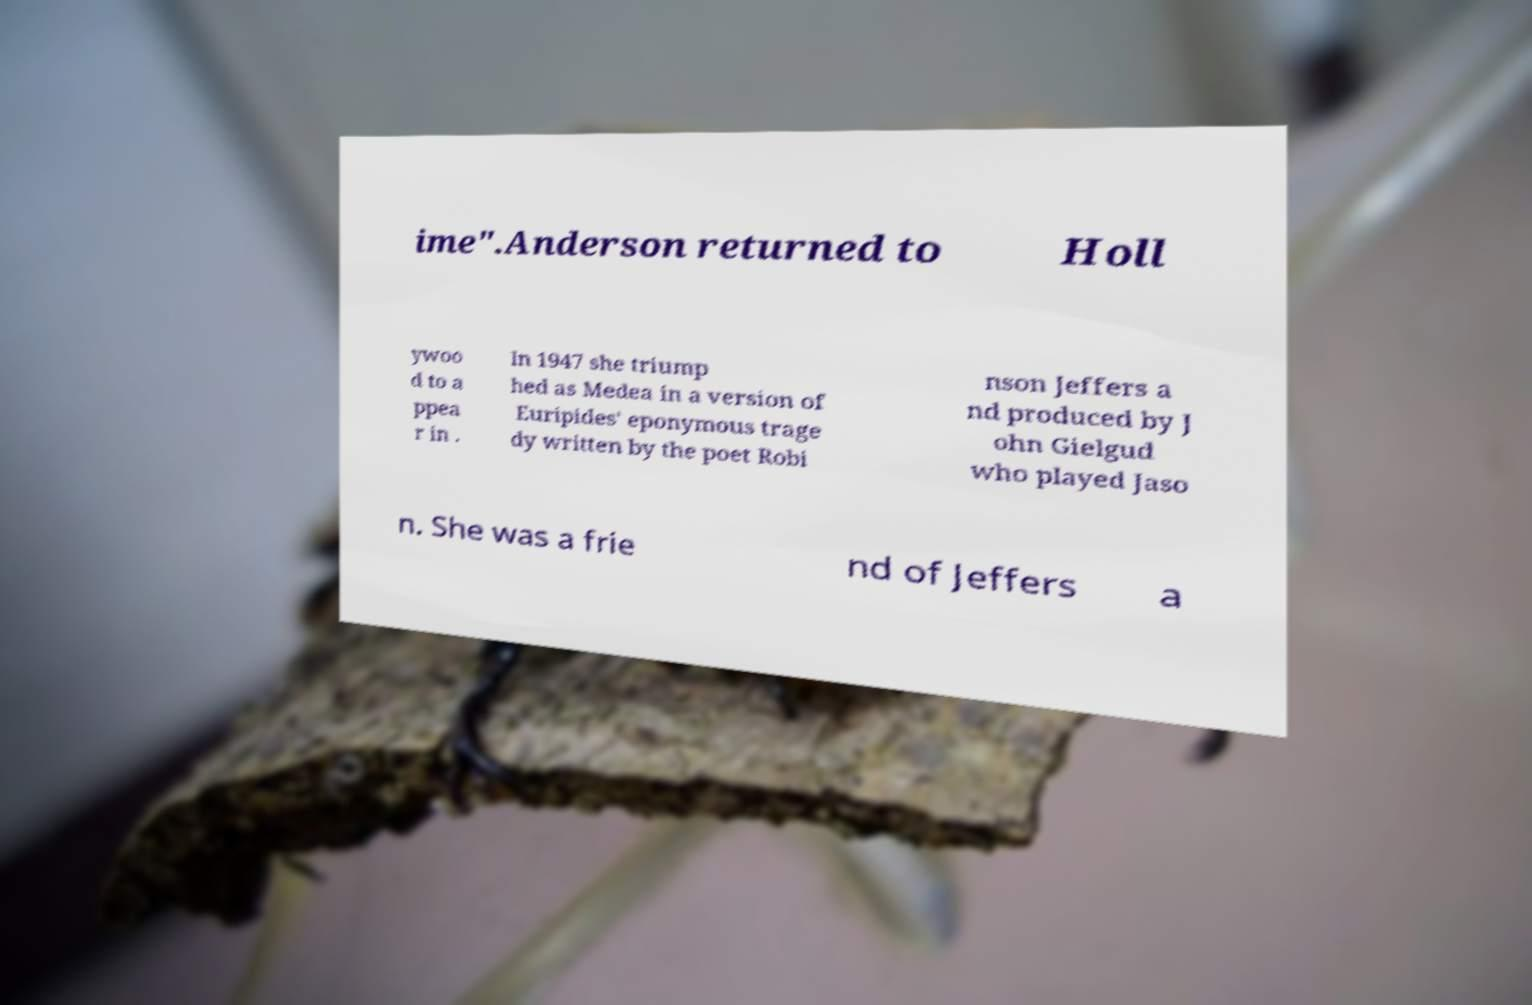Could you assist in decoding the text presented in this image and type it out clearly? ime".Anderson returned to Holl ywoo d to a ppea r in . In 1947 she triump hed as Medea in a version of Euripides' eponymous trage dy written by the poet Robi nson Jeffers a nd produced by J ohn Gielgud who played Jaso n. She was a frie nd of Jeffers a 